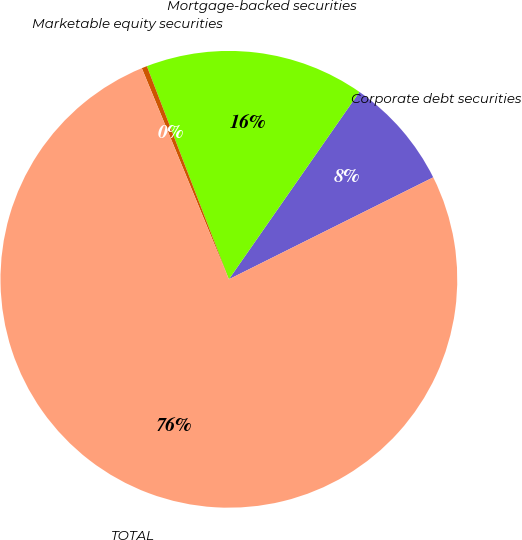Convert chart. <chart><loc_0><loc_0><loc_500><loc_500><pie_chart><fcel>Corporate debt securities<fcel>Mortgage-backed securities<fcel>Marketable equity securities<fcel>TOTAL<nl><fcel>7.95%<fcel>15.53%<fcel>0.38%<fcel>76.14%<nl></chart> 